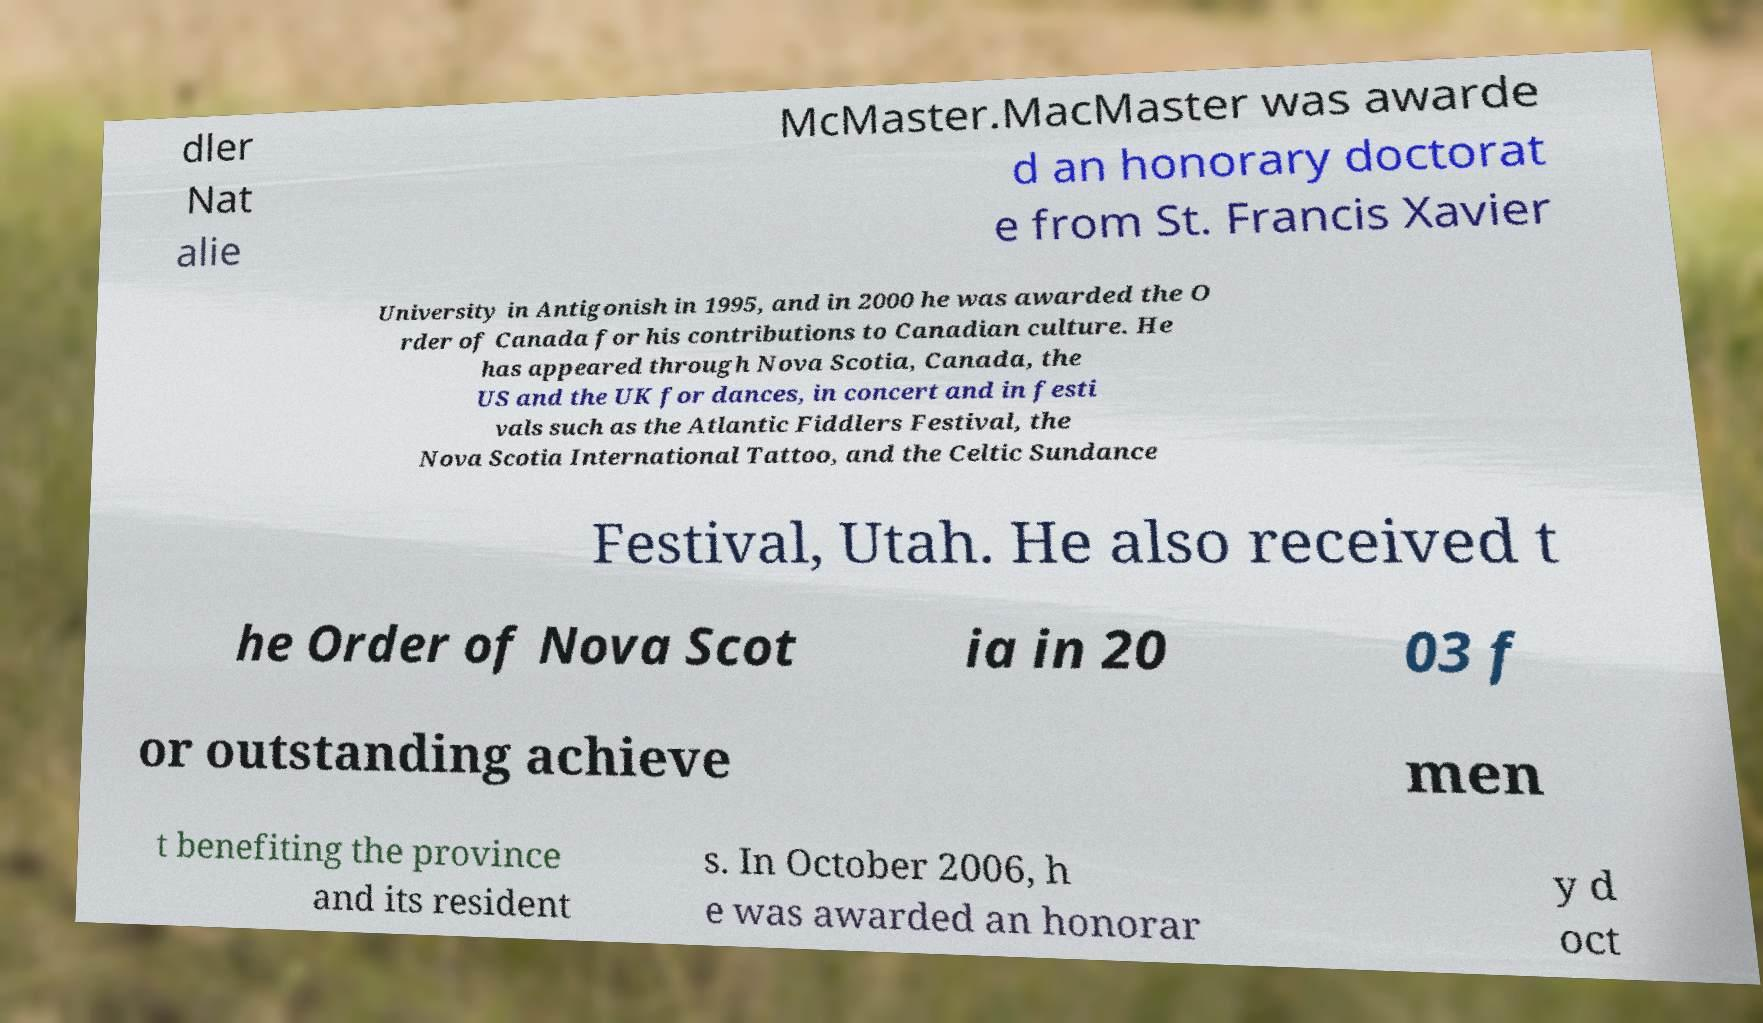I need the written content from this picture converted into text. Can you do that? dler Nat alie McMaster.MacMaster was awarde d an honorary doctorat e from St. Francis Xavier University in Antigonish in 1995, and in 2000 he was awarded the O rder of Canada for his contributions to Canadian culture. He has appeared through Nova Scotia, Canada, the US and the UK for dances, in concert and in festi vals such as the Atlantic Fiddlers Festival, the Nova Scotia International Tattoo, and the Celtic Sundance Festival, Utah. He also received t he Order of Nova Scot ia in 20 03 f or outstanding achieve men t benefiting the province and its resident s. In October 2006, h e was awarded an honorar y d oct 